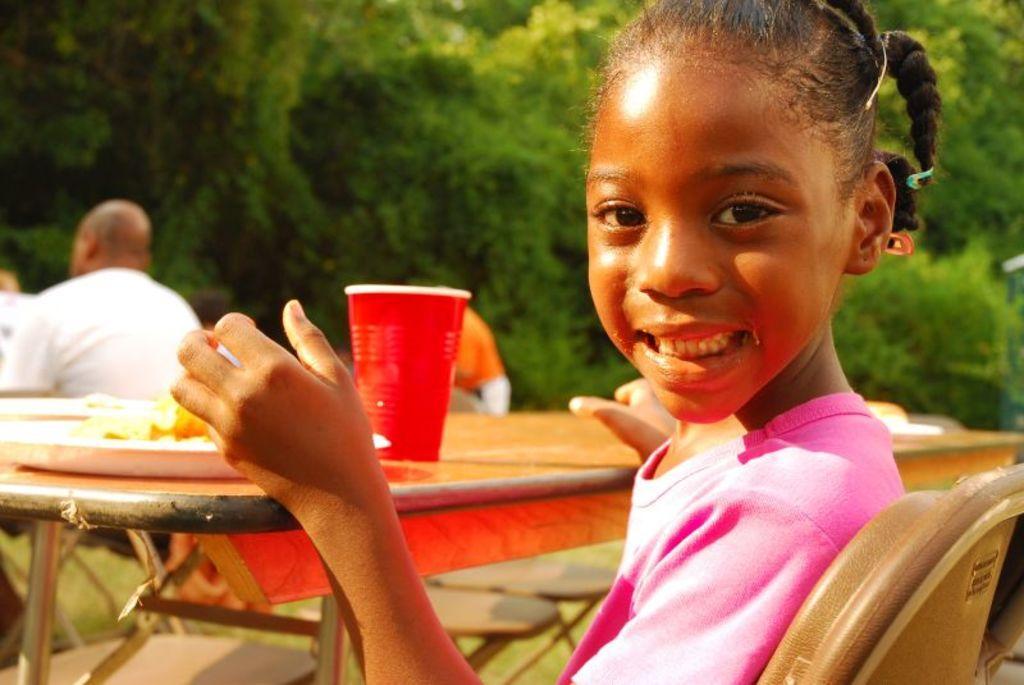How would you summarize this image in a sentence or two? I can see in this image a girl sitting on a chair in front of a table and some other people are sitting on a chair. On the table we have a cup, glass, plate and other objects on it. The girl is wearing a pink top and smiling. 